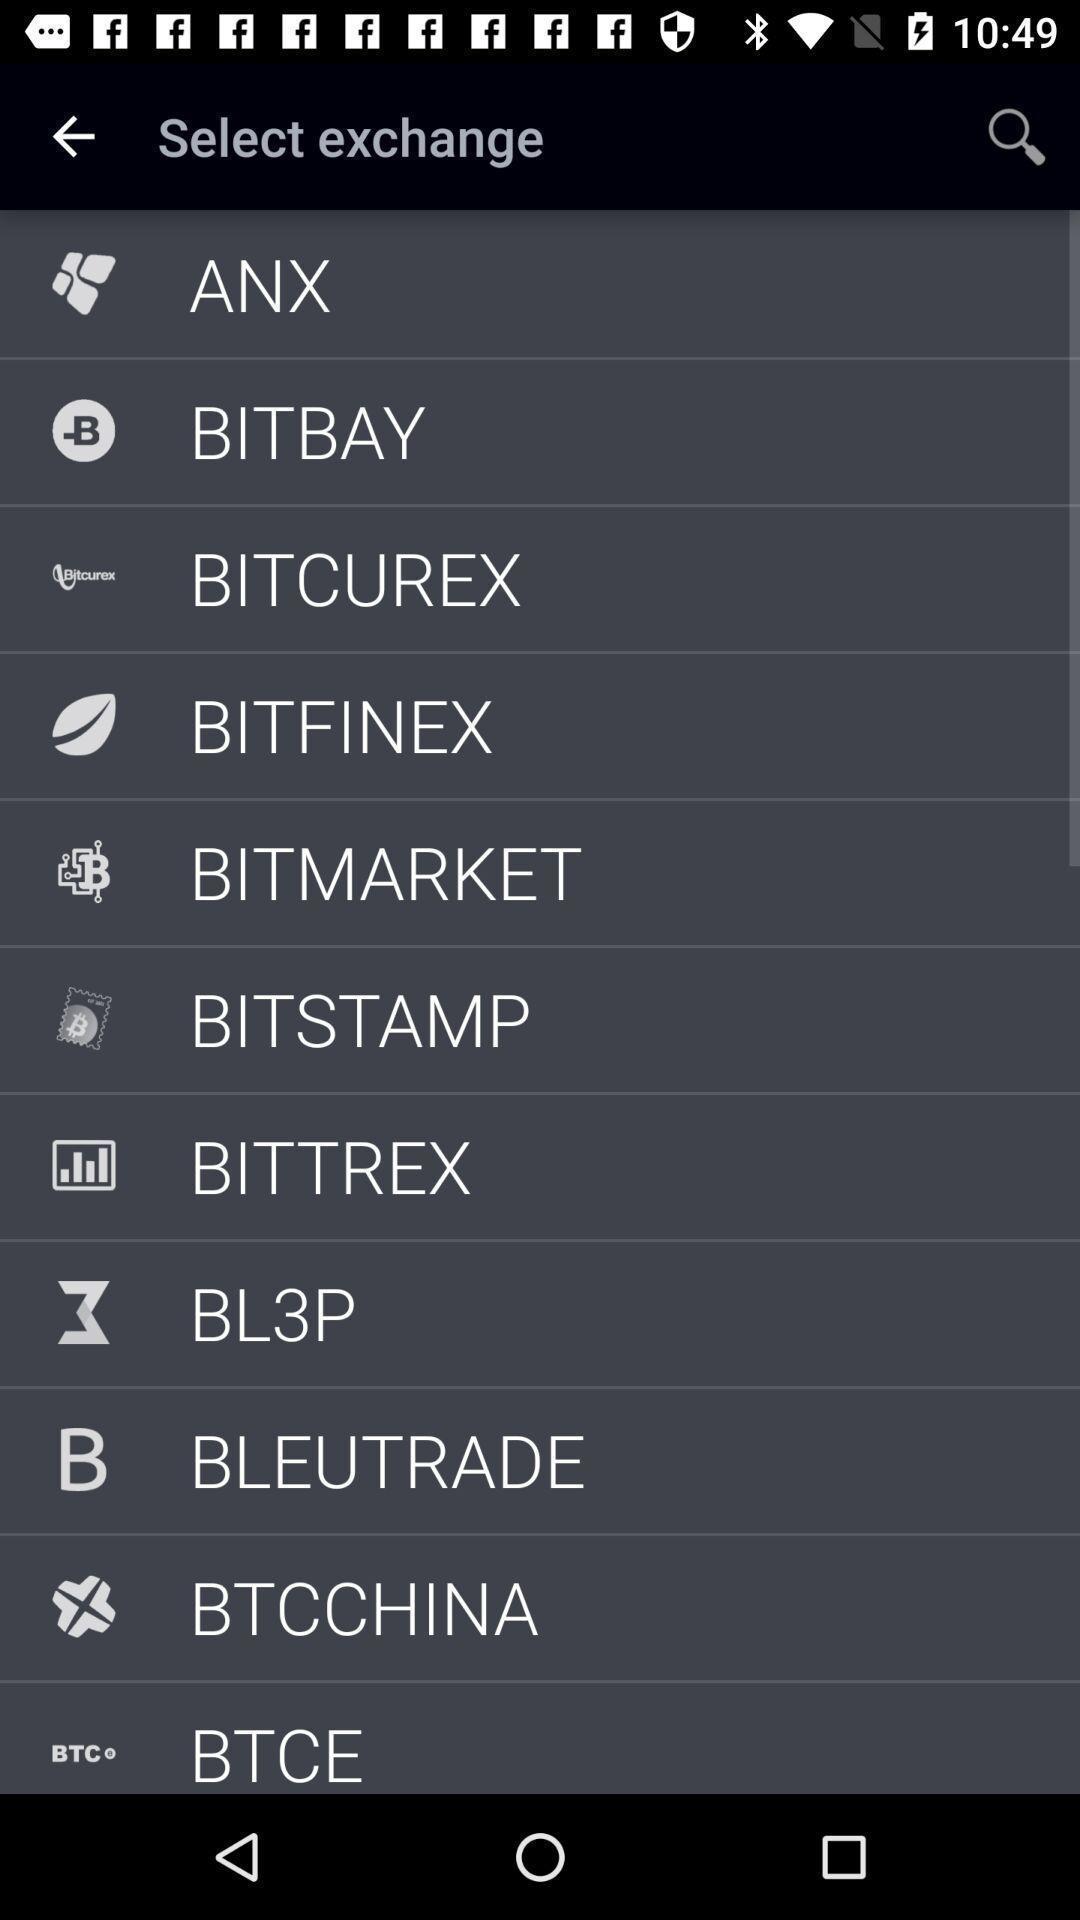Describe the key features of this screenshot. Page displaying the setting options. 